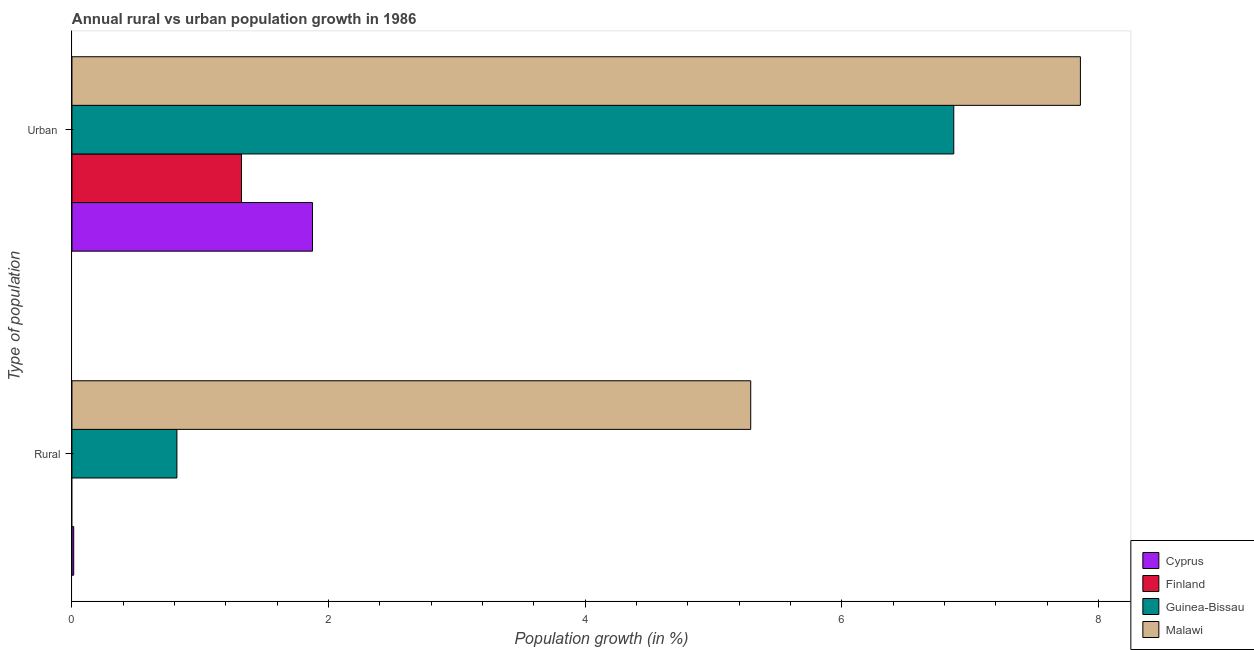How many different coloured bars are there?
Provide a short and direct response. 4. How many groups of bars are there?
Give a very brief answer. 2. Are the number of bars per tick equal to the number of legend labels?
Provide a succinct answer. No. Are the number of bars on each tick of the Y-axis equal?
Give a very brief answer. No. How many bars are there on the 2nd tick from the top?
Offer a terse response. 3. How many bars are there on the 1st tick from the bottom?
Offer a terse response. 3. What is the label of the 1st group of bars from the top?
Your answer should be very brief. Urban . What is the rural population growth in Malawi?
Your answer should be compact. 5.29. Across all countries, what is the maximum urban population growth?
Your answer should be compact. 7.86. Across all countries, what is the minimum urban population growth?
Provide a short and direct response. 1.32. In which country was the rural population growth maximum?
Provide a succinct answer. Malawi. What is the total urban population growth in the graph?
Your answer should be compact. 17.93. What is the difference between the urban population growth in Cyprus and that in Malawi?
Ensure brevity in your answer.  -5.98. What is the difference between the urban population growth in Cyprus and the rural population growth in Guinea-Bissau?
Keep it short and to the point. 1.06. What is the average rural population growth per country?
Keep it short and to the point. 1.53. What is the difference between the rural population growth and urban population growth in Malawi?
Offer a terse response. -2.57. What is the ratio of the urban population growth in Guinea-Bissau to that in Malawi?
Your response must be concise. 0.87. In how many countries, is the urban population growth greater than the average urban population growth taken over all countries?
Your answer should be very brief. 2. How many countries are there in the graph?
Offer a very short reply. 4. What is the difference between two consecutive major ticks on the X-axis?
Make the answer very short. 2. Does the graph contain any zero values?
Give a very brief answer. Yes. Does the graph contain grids?
Your answer should be compact. No. How are the legend labels stacked?
Offer a terse response. Vertical. What is the title of the graph?
Offer a very short reply. Annual rural vs urban population growth in 1986. Does "Guam" appear as one of the legend labels in the graph?
Your answer should be very brief. No. What is the label or title of the X-axis?
Offer a terse response. Population growth (in %). What is the label or title of the Y-axis?
Provide a short and direct response. Type of population. What is the Population growth (in %) of Cyprus in Rural?
Your answer should be very brief. 0.01. What is the Population growth (in %) in Guinea-Bissau in Rural?
Make the answer very short. 0.82. What is the Population growth (in %) of Malawi in Rural?
Ensure brevity in your answer.  5.29. What is the Population growth (in %) of Cyprus in Urban ?
Give a very brief answer. 1.87. What is the Population growth (in %) of Finland in Urban ?
Offer a terse response. 1.32. What is the Population growth (in %) of Guinea-Bissau in Urban ?
Your response must be concise. 6.87. What is the Population growth (in %) of Malawi in Urban ?
Provide a succinct answer. 7.86. Across all Type of population, what is the maximum Population growth (in %) in Cyprus?
Your answer should be compact. 1.87. Across all Type of population, what is the maximum Population growth (in %) in Finland?
Offer a terse response. 1.32. Across all Type of population, what is the maximum Population growth (in %) of Guinea-Bissau?
Keep it short and to the point. 6.87. Across all Type of population, what is the maximum Population growth (in %) in Malawi?
Ensure brevity in your answer.  7.86. Across all Type of population, what is the minimum Population growth (in %) of Cyprus?
Provide a short and direct response. 0.01. Across all Type of population, what is the minimum Population growth (in %) of Finland?
Keep it short and to the point. 0. Across all Type of population, what is the minimum Population growth (in %) in Guinea-Bissau?
Make the answer very short. 0.82. Across all Type of population, what is the minimum Population growth (in %) in Malawi?
Provide a succinct answer. 5.29. What is the total Population growth (in %) of Cyprus in the graph?
Provide a succinct answer. 1.89. What is the total Population growth (in %) in Finland in the graph?
Your answer should be very brief. 1.32. What is the total Population growth (in %) of Guinea-Bissau in the graph?
Your answer should be very brief. 7.69. What is the total Population growth (in %) in Malawi in the graph?
Your response must be concise. 13.15. What is the difference between the Population growth (in %) of Cyprus in Rural and that in Urban ?
Offer a very short reply. -1.86. What is the difference between the Population growth (in %) of Guinea-Bissau in Rural and that in Urban ?
Your answer should be very brief. -6.05. What is the difference between the Population growth (in %) in Malawi in Rural and that in Urban ?
Provide a succinct answer. -2.57. What is the difference between the Population growth (in %) in Cyprus in Rural and the Population growth (in %) in Finland in Urban ?
Your answer should be compact. -1.31. What is the difference between the Population growth (in %) in Cyprus in Rural and the Population growth (in %) in Guinea-Bissau in Urban ?
Offer a very short reply. -6.86. What is the difference between the Population growth (in %) of Cyprus in Rural and the Population growth (in %) of Malawi in Urban ?
Your answer should be very brief. -7.85. What is the difference between the Population growth (in %) in Guinea-Bissau in Rural and the Population growth (in %) in Malawi in Urban ?
Your answer should be very brief. -7.04. What is the average Population growth (in %) of Cyprus per Type of population?
Offer a terse response. 0.94. What is the average Population growth (in %) in Finland per Type of population?
Offer a terse response. 0.66. What is the average Population growth (in %) of Guinea-Bissau per Type of population?
Ensure brevity in your answer.  3.85. What is the average Population growth (in %) of Malawi per Type of population?
Offer a very short reply. 6.57. What is the difference between the Population growth (in %) in Cyprus and Population growth (in %) in Guinea-Bissau in Rural?
Keep it short and to the point. -0.8. What is the difference between the Population growth (in %) in Cyprus and Population growth (in %) in Malawi in Rural?
Your answer should be compact. -5.28. What is the difference between the Population growth (in %) of Guinea-Bissau and Population growth (in %) of Malawi in Rural?
Offer a very short reply. -4.47. What is the difference between the Population growth (in %) in Cyprus and Population growth (in %) in Finland in Urban ?
Your answer should be compact. 0.55. What is the difference between the Population growth (in %) of Cyprus and Population growth (in %) of Guinea-Bissau in Urban ?
Give a very brief answer. -5. What is the difference between the Population growth (in %) of Cyprus and Population growth (in %) of Malawi in Urban ?
Offer a very short reply. -5.98. What is the difference between the Population growth (in %) of Finland and Population growth (in %) of Guinea-Bissau in Urban ?
Offer a terse response. -5.55. What is the difference between the Population growth (in %) of Finland and Population growth (in %) of Malawi in Urban ?
Your answer should be compact. -6.54. What is the difference between the Population growth (in %) in Guinea-Bissau and Population growth (in %) in Malawi in Urban ?
Offer a terse response. -0.99. What is the ratio of the Population growth (in %) in Cyprus in Rural to that in Urban ?
Your answer should be compact. 0.01. What is the ratio of the Population growth (in %) in Guinea-Bissau in Rural to that in Urban ?
Give a very brief answer. 0.12. What is the ratio of the Population growth (in %) of Malawi in Rural to that in Urban ?
Your answer should be very brief. 0.67. What is the difference between the highest and the second highest Population growth (in %) in Cyprus?
Make the answer very short. 1.86. What is the difference between the highest and the second highest Population growth (in %) of Guinea-Bissau?
Your response must be concise. 6.05. What is the difference between the highest and the second highest Population growth (in %) of Malawi?
Your response must be concise. 2.57. What is the difference between the highest and the lowest Population growth (in %) in Cyprus?
Keep it short and to the point. 1.86. What is the difference between the highest and the lowest Population growth (in %) in Finland?
Keep it short and to the point. 1.32. What is the difference between the highest and the lowest Population growth (in %) in Guinea-Bissau?
Keep it short and to the point. 6.05. What is the difference between the highest and the lowest Population growth (in %) of Malawi?
Ensure brevity in your answer.  2.57. 